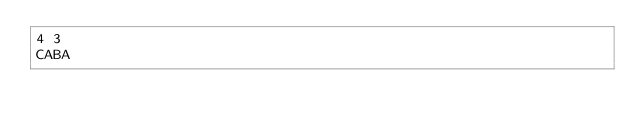<code> <loc_0><loc_0><loc_500><loc_500><_C#_>4 3
CABA</code> 